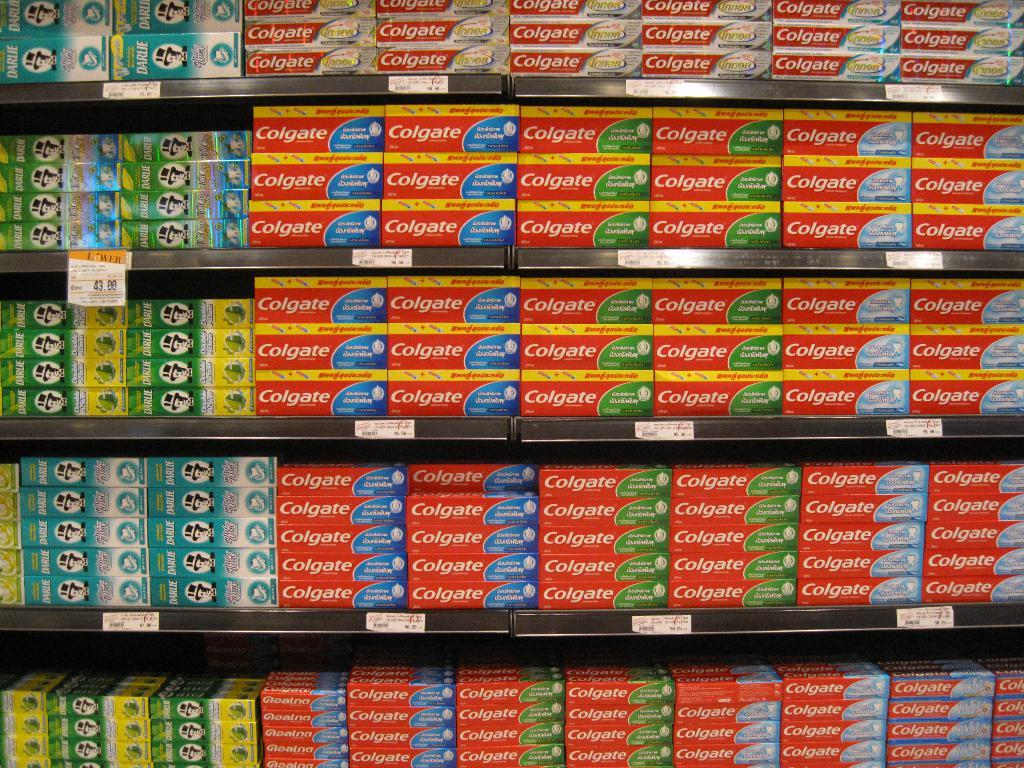Provide a one-sentence caption for the provided image. Store selling many bottles of toothpaste including Colgate. 